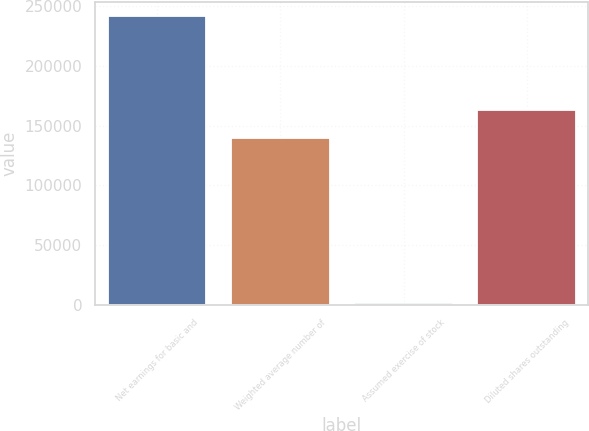<chart> <loc_0><loc_0><loc_500><loc_500><bar_chart><fcel>Net earnings for basic and<fcel>Weighted average number of<fcel>Assumed exercise of stock<fcel>Diluted shares outstanding<nl><fcel>241686<fcel>139353<fcel>1421<fcel>163380<nl></chart> 